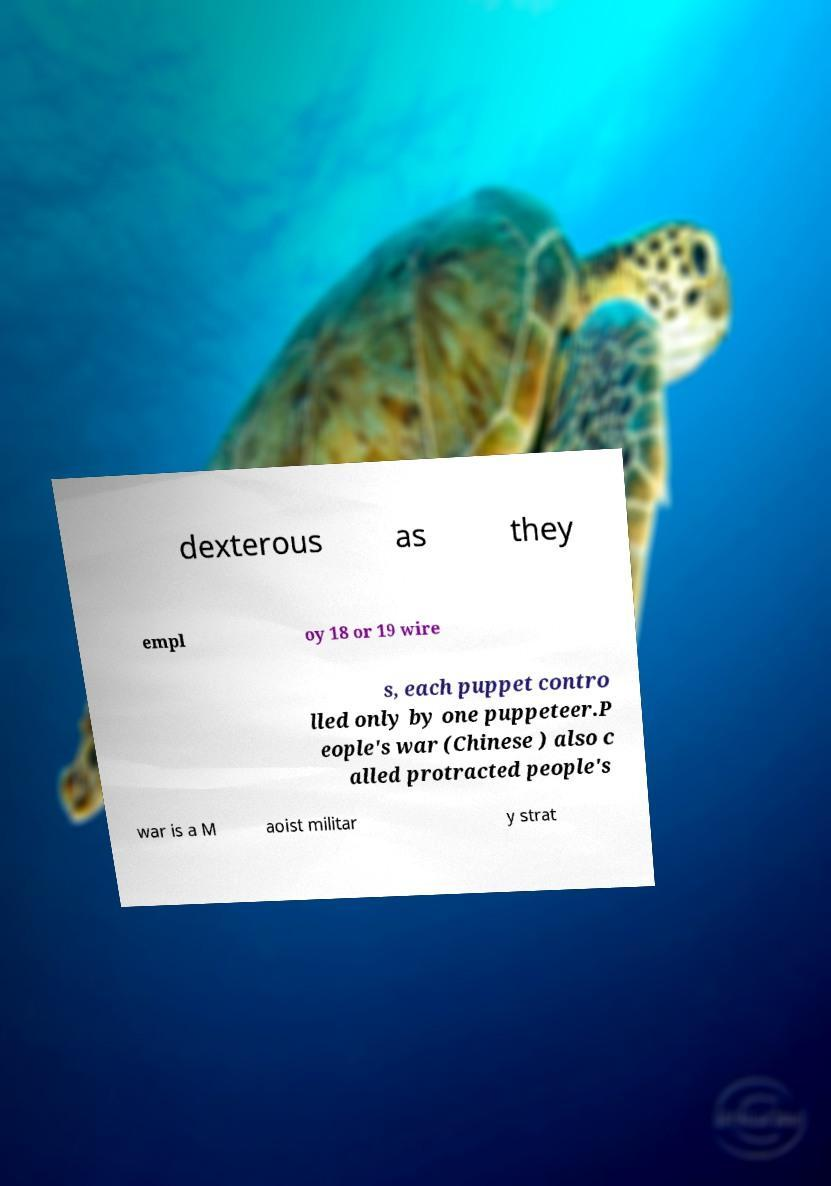Please identify and transcribe the text found in this image. dexterous as they empl oy 18 or 19 wire s, each puppet contro lled only by one puppeteer.P eople's war (Chinese ) also c alled protracted people's war is a M aoist militar y strat 